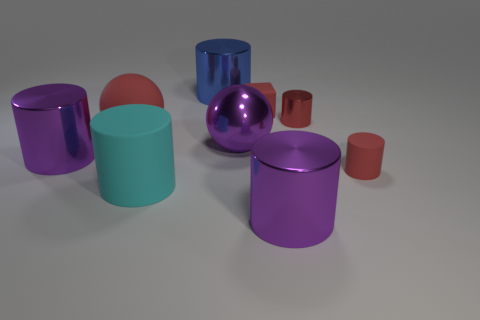Subtract all tiny cylinders. How many cylinders are left? 4 Subtract all cyan cubes. How many purple cylinders are left? 2 Subtract all red cylinders. How many cylinders are left? 4 Subtract 2 cylinders. How many cylinders are left? 4 Add 1 big cylinders. How many objects exist? 10 Subtract all brown cylinders. Subtract all gray cubes. How many cylinders are left? 6 Subtract all big rubber cubes. Subtract all big purple metallic cylinders. How many objects are left? 7 Add 5 small metal cylinders. How many small metal cylinders are left? 6 Add 7 large purple spheres. How many large purple spheres exist? 8 Subtract 0 brown blocks. How many objects are left? 9 